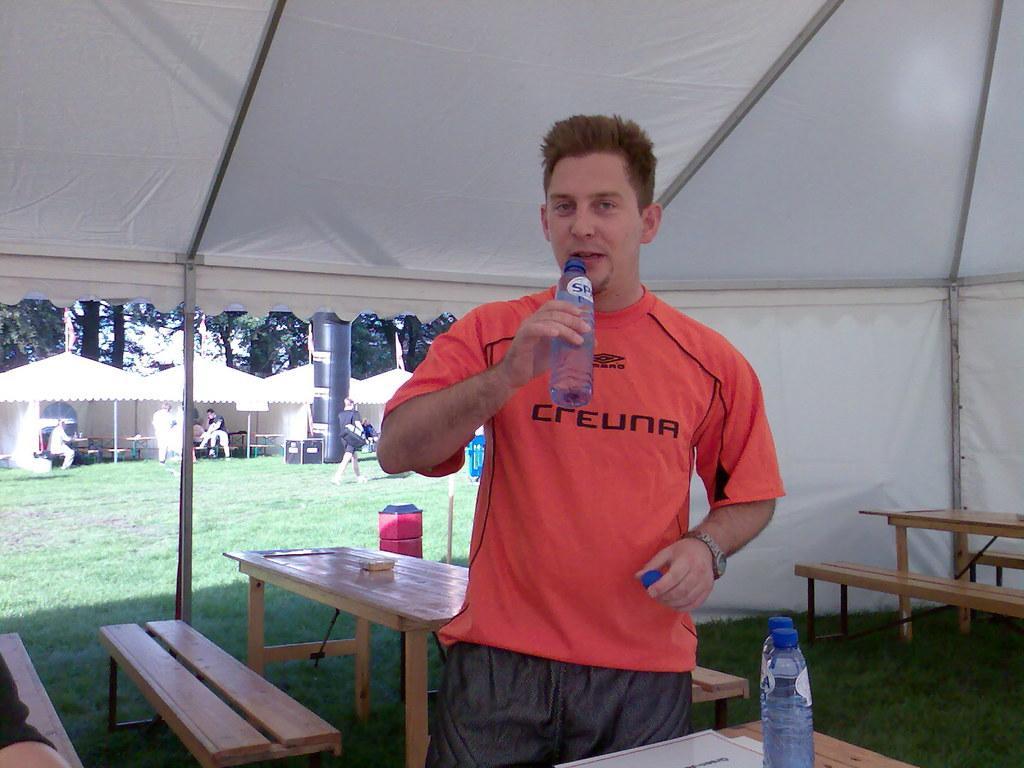In one or two sentences, can you explain what this image depicts? In this image there is a person standing under the tent is holding a bottle is having a watch. Before him there is a table having two bottles and papers on it. This is a grassy land. A person is walking on grass. Background there are few tents in which few people are sitting and few are standing. The background of image there are few trees. 